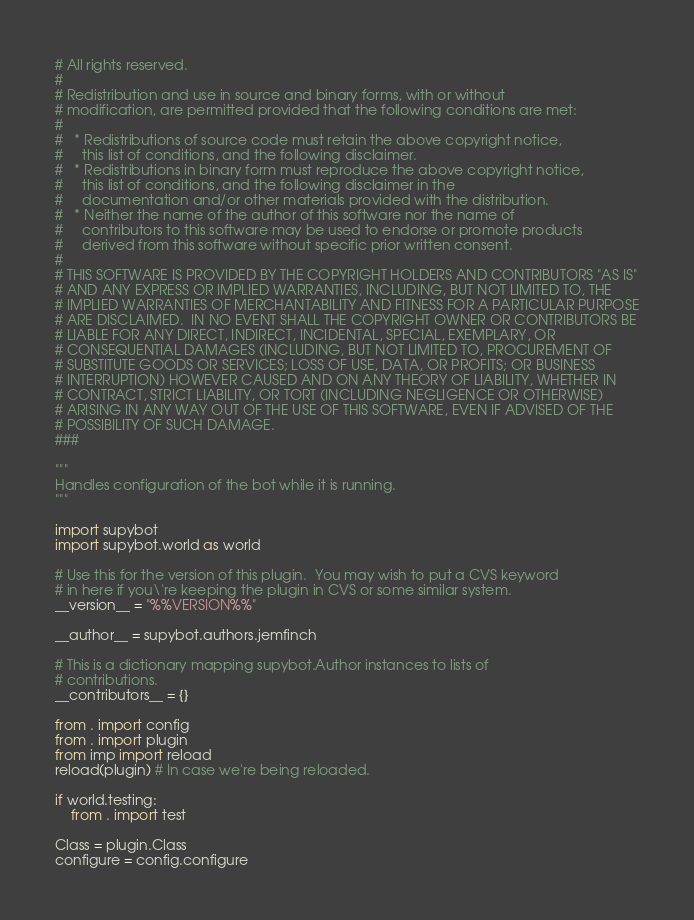<code> <loc_0><loc_0><loc_500><loc_500><_Python_># All rights reserved.
#
# Redistribution and use in source and binary forms, with or without
# modification, are permitted provided that the following conditions are met:
#
#   * Redistributions of source code must retain the above copyright notice,
#     this list of conditions, and the following disclaimer.
#   * Redistributions in binary form must reproduce the above copyright notice,
#     this list of conditions, and the following disclaimer in the
#     documentation and/or other materials provided with the distribution.
#   * Neither the name of the author of this software nor the name of
#     contributors to this software may be used to endorse or promote products
#     derived from this software without specific prior written consent.
#
# THIS SOFTWARE IS PROVIDED BY THE COPYRIGHT HOLDERS AND CONTRIBUTORS "AS IS"
# AND ANY EXPRESS OR IMPLIED WARRANTIES, INCLUDING, BUT NOT LIMITED TO, THE
# IMPLIED WARRANTIES OF MERCHANTABILITY AND FITNESS FOR A PARTICULAR PURPOSE
# ARE DISCLAIMED.  IN NO EVENT SHALL THE COPYRIGHT OWNER OR CONTRIBUTORS BE
# LIABLE FOR ANY DIRECT, INDIRECT, INCIDENTAL, SPECIAL, EXEMPLARY, OR
# CONSEQUENTIAL DAMAGES (INCLUDING, BUT NOT LIMITED TO, PROCUREMENT OF
# SUBSTITUTE GOODS OR SERVICES; LOSS OF USE, DATA, OR PROFITS; OR BUSINESS
# INTERRUPTION) HOWEVER CAUSED AND ON ANY THEORY OF LIABILITY, WHETHER IN
# CONTRACT, STRICT LIABILITY, OR TORT (INCLUDING NEGLIGENCE OR OTHERWISE)
# ARISING IN ANY WAY OUT OF THE USE OF THIS SOFTWARE, EVEN IF ADVISED OF THE
# POSSIBILITY OF SUCH DAMAGE.
###

"""
Handles configuration of the bot while it is running.
"""

import supybot
import supybot.world as world

# Use this for the version of this plugin.  You may wish to put a CVS keyword
# in here if you\'re keeping the plugin in CVS or some similar system.
__version__ = "%%VERSION%%"

__author__ = supybot.authors.jemfinch

# This is a dictionary mapping supybot.Author instances to lists of
# contributions.
__contributors__ = {}

from . import config
from . import plugin
from imp import reload
reload(plugin) # In case we're being reloaded.

if world.testing:
    from . import test

Class = plugin.Class
configure = config.configure
</code> 